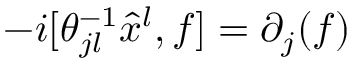Convert formula to latex. <formula><loc_0><loc_0><loc_500><loc_500>- i [ \theta _ { j l } ^ { - 1 } \hat { x } ^ { l } , f ] = \partial _ { j } ( f )</formula> 